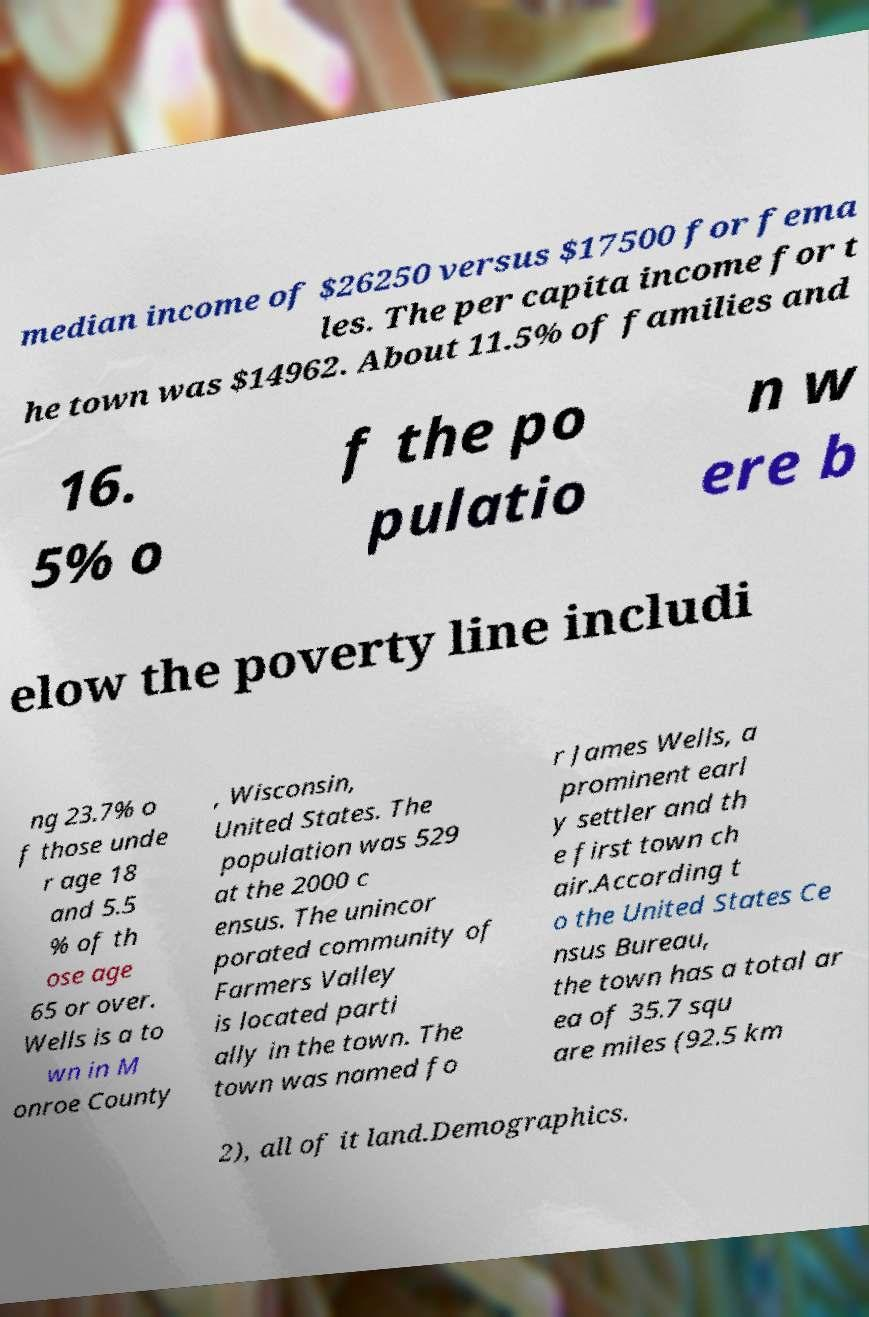Could you extract and type out the text from this image? median income of $26250 versus $17500 for fema les. The per capita income for t he town was $14962. About 11.5% of families and 16. 5% o f the po pulatio n w ere b elow the poverty line includi ng 23.7% o f those unde r age 18 and 5.5 % of th ose age 65 or over. Wells is a to wn in M onroe County , Wisconsin, United States. The population was 529 at the 2000 c ensus. The unincor porated community of Farmers Valley is located parti ally in the town. The town was named fo r James Wells, a prominent earl y settler and th e first town ch air.According t o the United States Ce nsus Bureau, the town has a total ar ea of 35.7 squ are miles (92.5 km 2), all of it land.Demographics. 